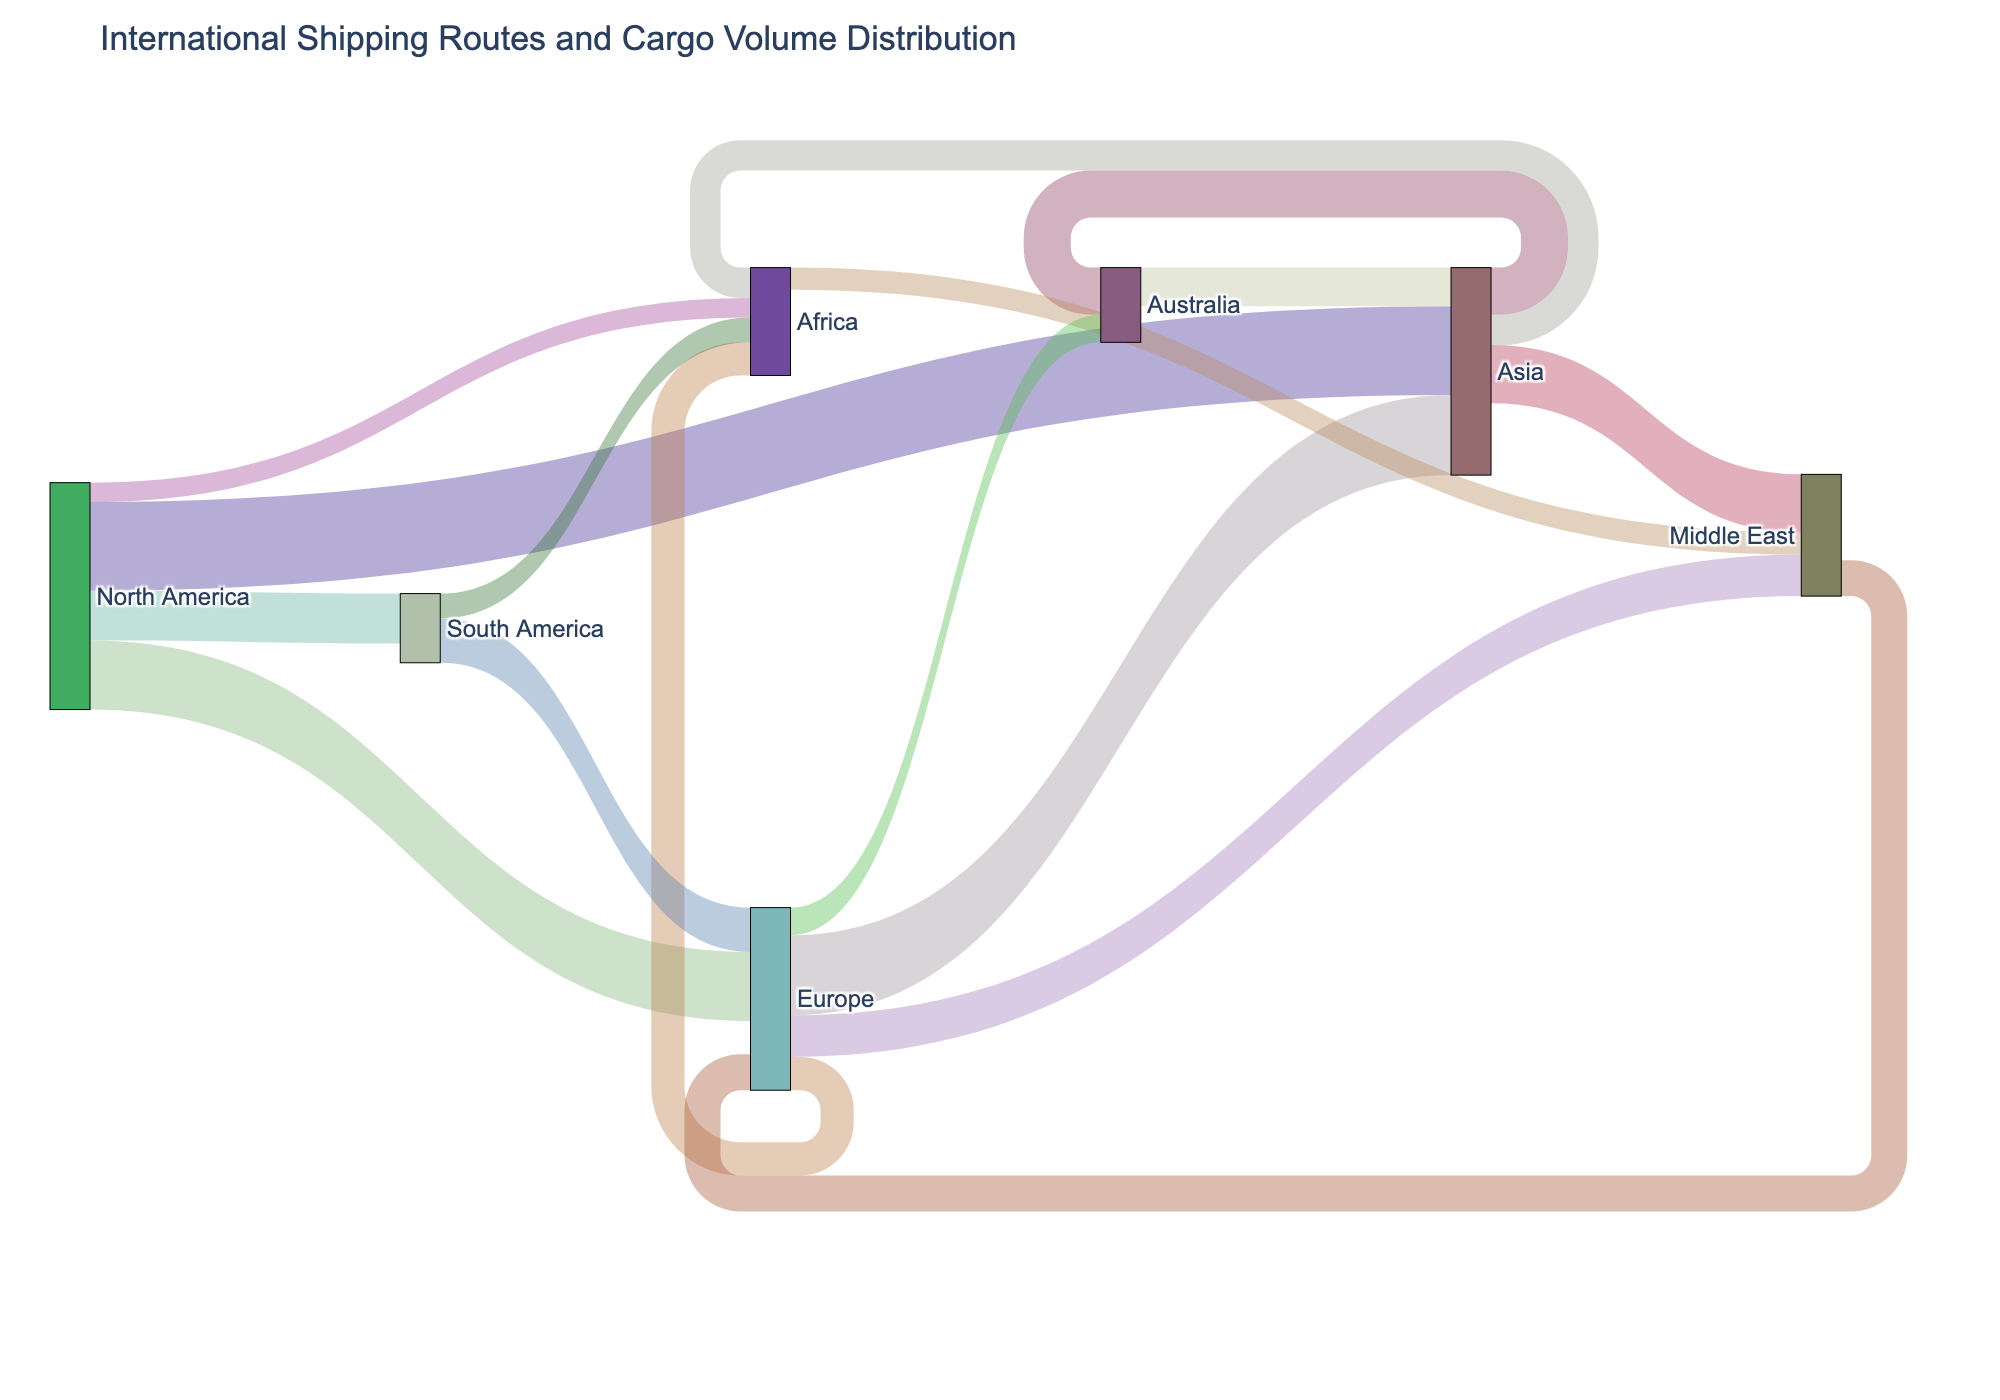What is the title of the diagram? The title of the diagram is usually placed at the top, summarizing the visual representation. In this case, we look at the top of the diagram.
Answer: International Shipping Routes and Cargo Volume Distribution How many connections involve North America? Count all the lines (or connections) that either start from or end at the North America node.
Answer: 4 Which route has the highest cargo volume? Identify the line with the largest value associated with it. This is the number next to the thickest line.
Answer: North America to Asia What is the total cargo volume originating from Europe? Sum the values of all connections that have Europe as the source node. So, 2900000 (Europe to Asia) + 1200000 (Europe to Africa) + 1500000 (Europe to Middle East) + 1000000 (Europe to Australia) = 6600000.
Answer: 6600000 Which continents have cargo routes to Africa? Look at all the lines that end at Africa and identify their starting points.
Answer: Europe, South America, Asia, North America What is the cargo volume from South America to Europe? Identify the connection between South America and Europe and check the value associated with it.
Answer: 1600000 What's the average cargo volume for routes originating in Asia? Sum the values of all connections that originate from Asia and divide by the number of such connections. So, (1700000 + 2100000 + 1100000) / 3 = 1633333.33.
Answer: 1633333.33 Which continents does the Middle East receive cargo from? Look at all the lines that end at the Middle East and identify their starting points.
Answer: Europe, Asia, Africa Is the cargo volume from Australia to Asia greater than from North America to South America? Compare the values: Australia to Asia (1400000) and North America to South America (1800000). 1400000 is less than 1800000.
Answer: No What is the difference in cargo volume between the routes from Europe to the Middle East and from Africa to the Middle East? Subtract the cargo volume from Africa to the Middle East (800000) from the cargo volume from Europe to the Middle East (1500000). So, 1500000 - 800000 = 700000.
Answer: 700000 